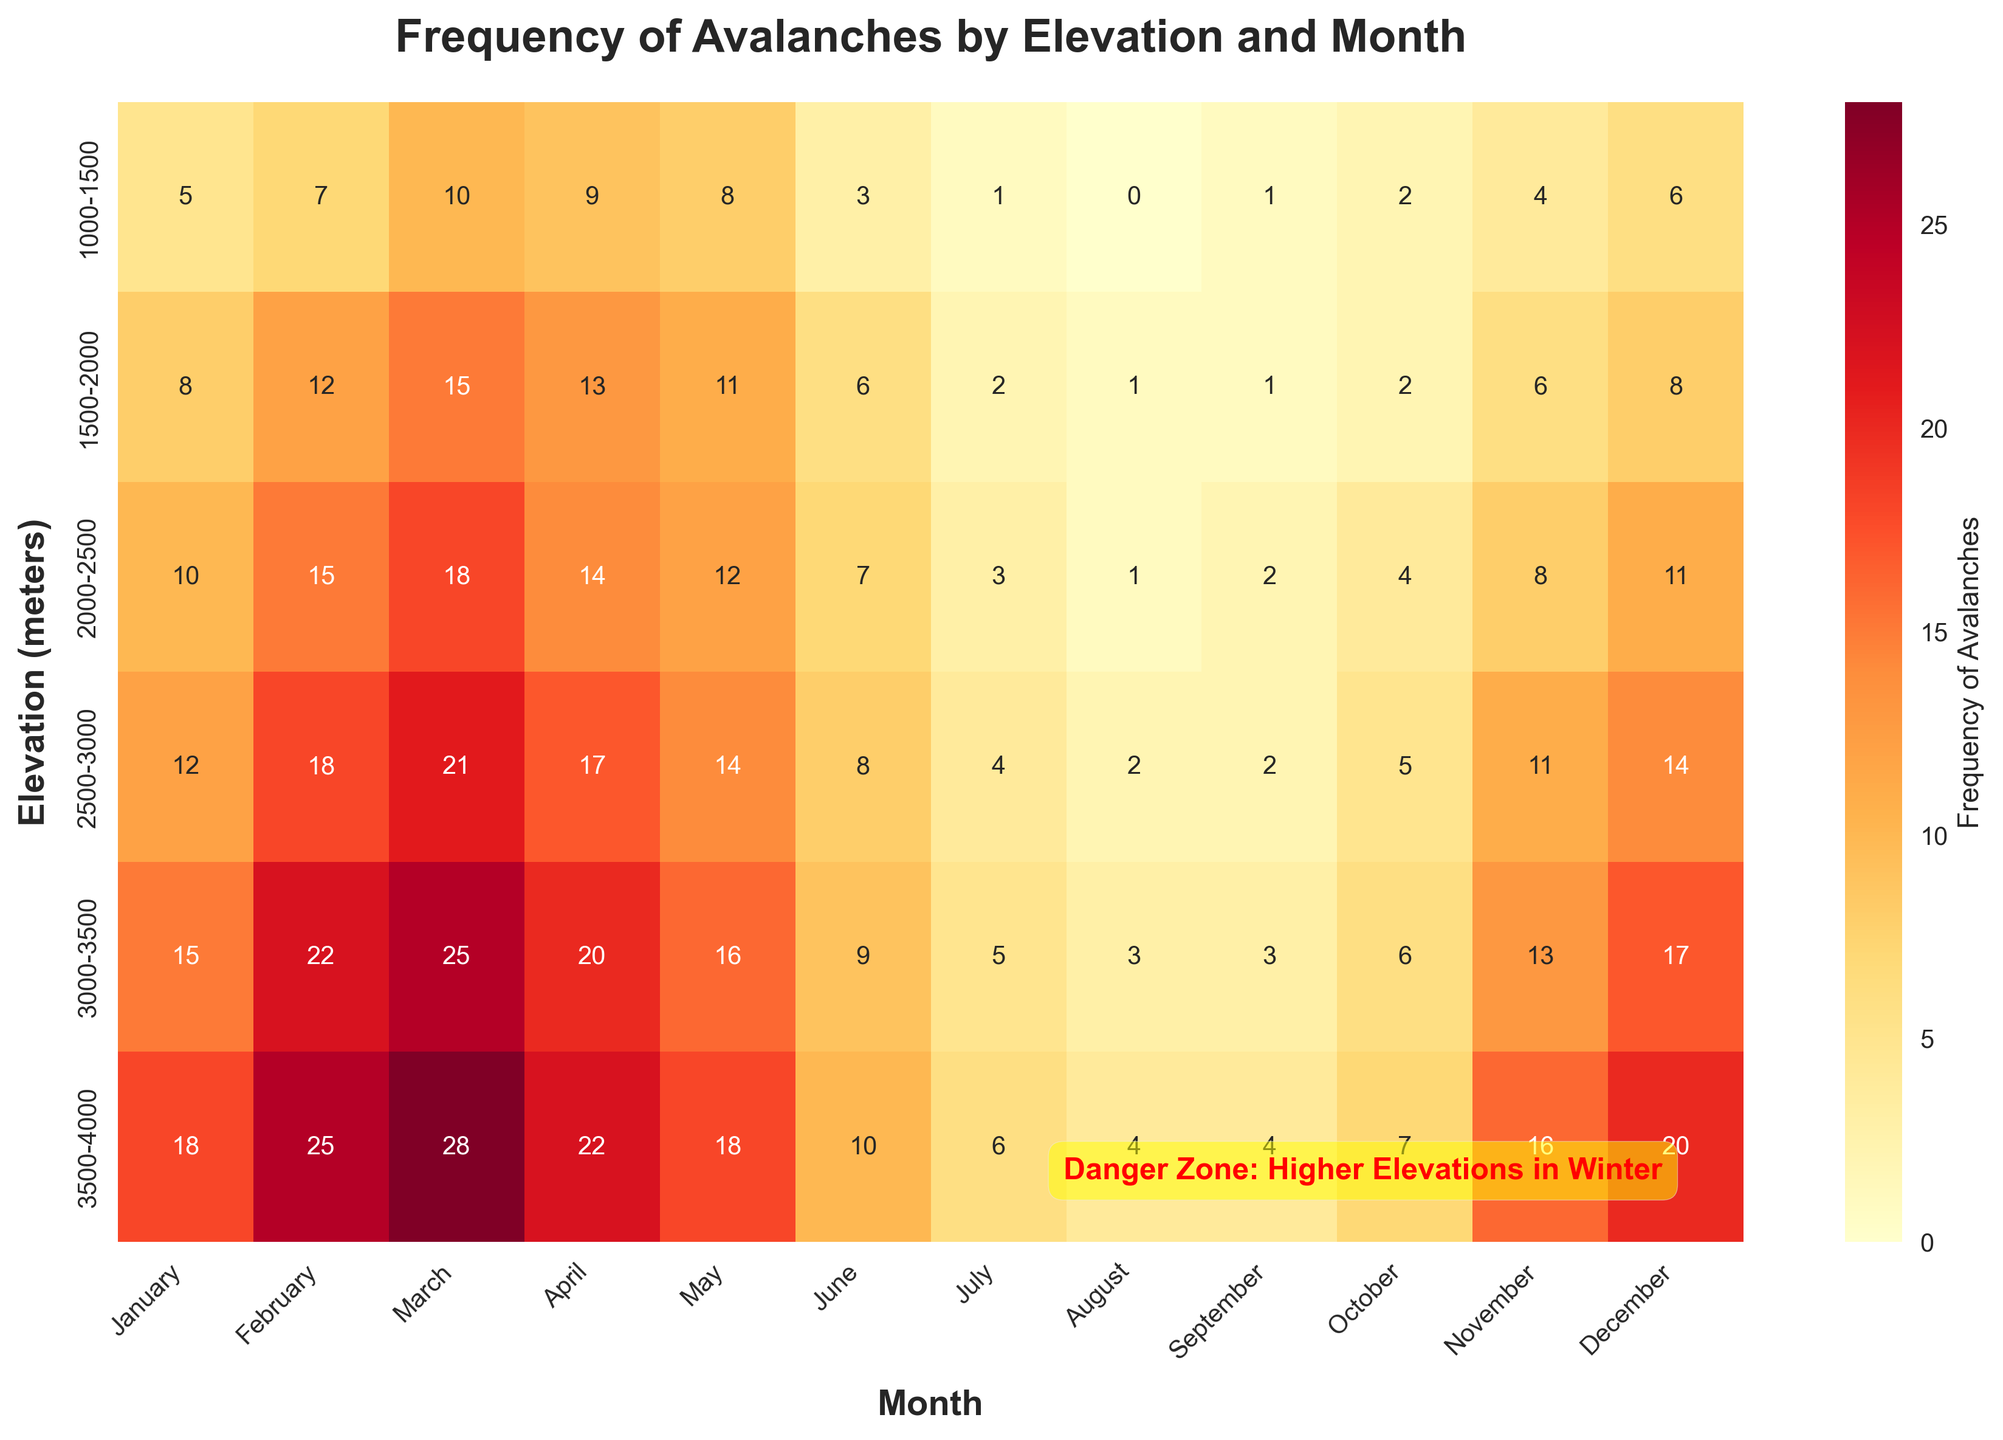What is the title of the heatmap? The title is displayed at the top of the heatmap and generally describes the data shown. For this heatmap, the title is “Frequency of Avalanches by Elevation and Month”.
Answer: Frequency of Avalanches by Elevation and Month Which month has the highest frequency of avalanches at the 3500-4000 meters elevation level? Look at the row for 3500-4000 meters and identify the month with the highest number in that row. The number 28 appears in March.
Answer: March How many avalanches were reported in September at the elevation level 3000-3500 meters? Locate the row for 3000-3500 meters and then find the cell corresponding to September. The value in this cell is 3.
Answer: 3 What is the average frequency of avalanches in January across all elevation levels? Add the numbers from the January column (5+8+10+12+15+18=68) and divide by 6 (number of elevation levels).
Answer: 11.3 Which elevation level has the most significant increase in avalanche frequency from January to February? Calculate the difference between the January and February frequencies for each elevation level. The differences are (7-5=2), (12-8=4), (15-10=5), (18-12=6), (22-15=7), (25-18=7). The highest increase is 7, occurring at 3000-3500 meters and 3500-4000 meters.
Answer: 3000-3500 and 3500-4000 Compare the avalanche frequencies in April and October for the 2500-3000 meters elevation level. Which month has a higher frequency? Locate the frequencies for April and October in the 2500-3000 meters row. April has 17 avalanches and October has 5.
Answer: April Which elevation level has the lowest frequency of avalanches in July? Look at the July column and identify the lowest number. The frequency of 1 corresponds to the 1000-1500 meters elevation level.
Answer: 1000-1500 meters What is the total number of avalanches recorded at the 2000-2500 meters elevation level throughout the year? Add the numbers in the 2000-2500 meters row: 10 + 15 + 18 + 14 + 12 + 7 + 3 + 1 + 2 + 4 + 8 + 11 = 105.
Answer: 105 How does the frequency of avalanches in December at the 3500-4000 meters compare to that in June at the same elevation? Look at the December and June columns for the 3500-4000 meters row. December has 20 avalanches, and June has 10.
Answer: December is 10 more than June Which elevation levels have a higher frequency of avalanches in May compared to August? Compare the values in the May and August columns for each row. The elevations with higher values in May than August are 1000-1500 (8 > 0), 1500-2000 (11 > 1), 2000-2500 (12 > 1), 2500-3000 (14 > 2), 3000-3500 (16 > 3), and 3500-4000 (18 > 4).
Answer: All elevation levels 